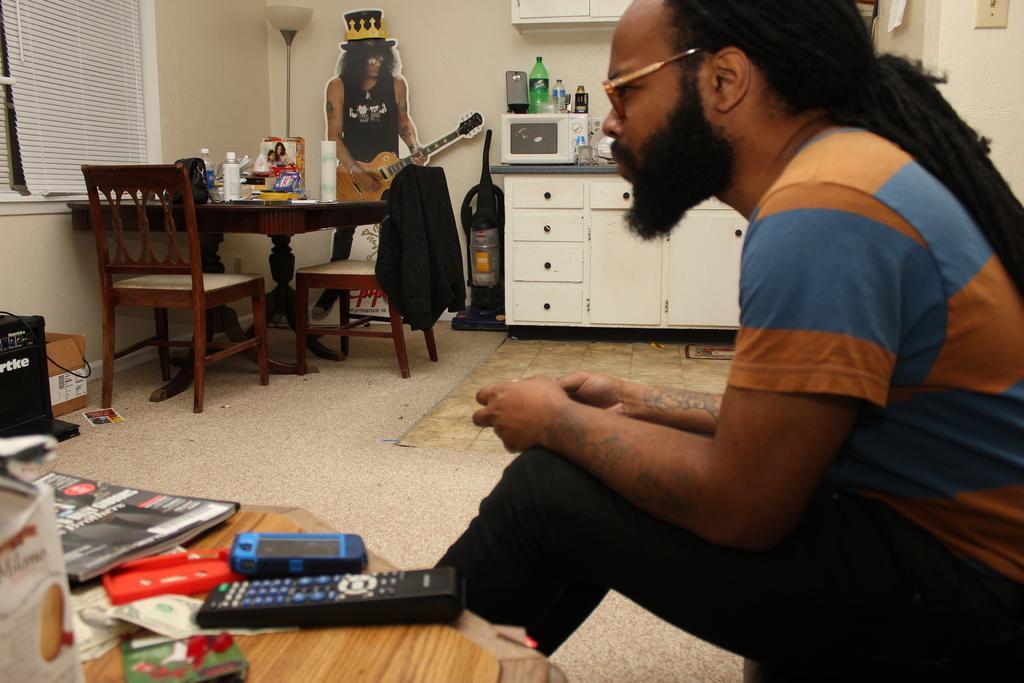Could you give a brief overview of what you see in this image? In this picture we can see men sitting and beside to him on table we can see remote, box, book, papers and in background we can see table with bottle, bag on it, chairs, poster holding guitar man, cupboards, microwave oven, window, wall, lamp. 